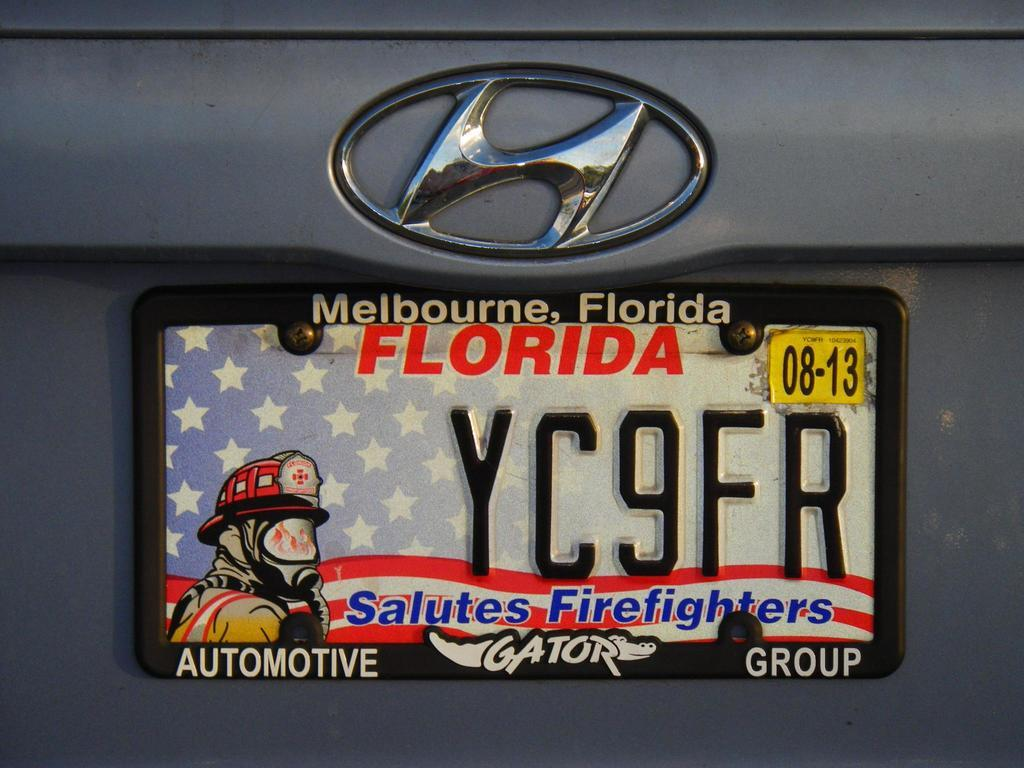<image>
Render a clear and concise summary of the photo. Hyundai car with a melbourne florida salutes firefighters tag 